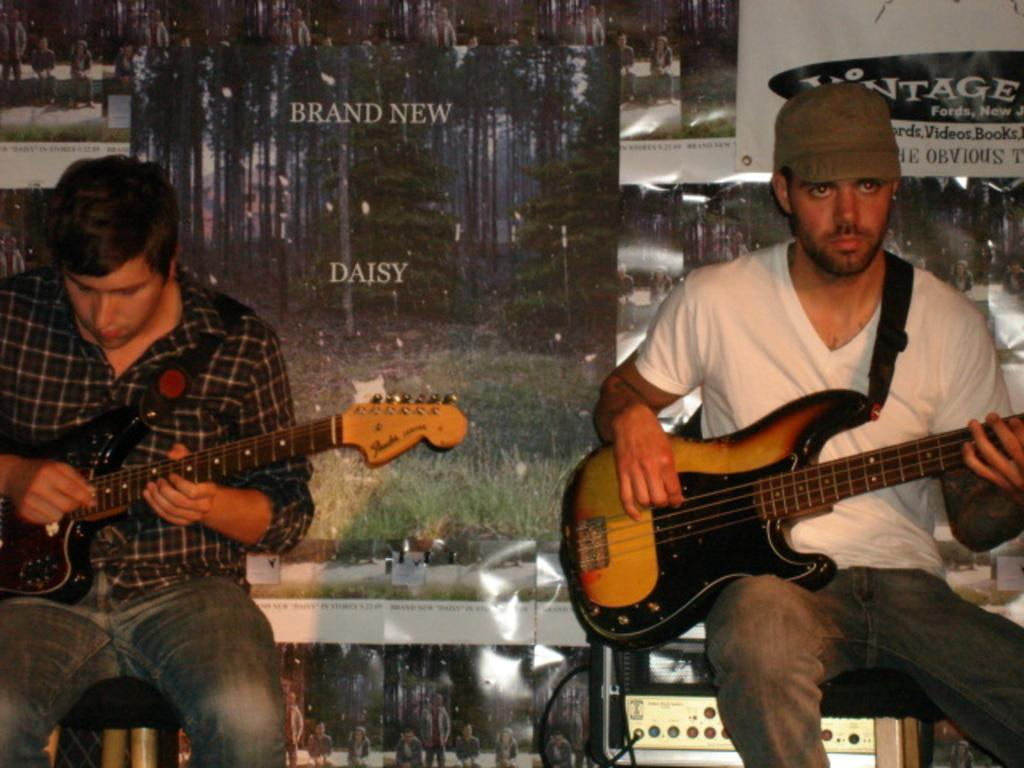How many people are in the image? There are two men in the image. What are the men doing in the image? The men are sitting and holding guitars. Can you describe the clothing of one of the men? One of the men is wearing a cap. What can be seen on the wall in the background of the image? There are banners on the wall in the background. What type of food is the man in the cap eating in the image? There is no food present in the image; the man in the cap is holding a guitar and sitting with another man. 